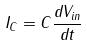<formula> <loc_0><loc_0><loc_500><loc_500>I _ { C } = C \frac { d V _ { i n } } { d t }</formula> 